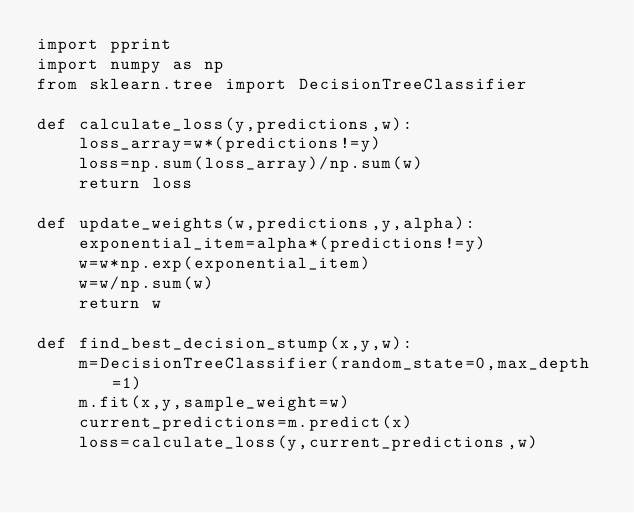<code> <loc_0><loc_0><loc_500><loc_500><_Python_>import pprint
import numpy as np
from sklearn.tree import DecisionTreeClassifier

def calculate_loss(y,predictions,w):
    loss_array=w*(predictions!=y)
    loss=np.sum(loss_array)/np.sum(w)
    return loss

def update_weights(w,predictions,y,alpha):
    exponential_item=alpha*(predictions!=y)
    w=w*np.exp(exponential_item)
    w=w/np.sum(w)
    return w

def find_best_decision_stump(x,y,w):
    m=DecisionTreeClassifier(random_state=0,max_depth=1)
    m.fit(x,y,sample_weight=w)
    current_predictions=m.predict(x)
    loss=calculate_loss(y,current_predictions,w)</code> 